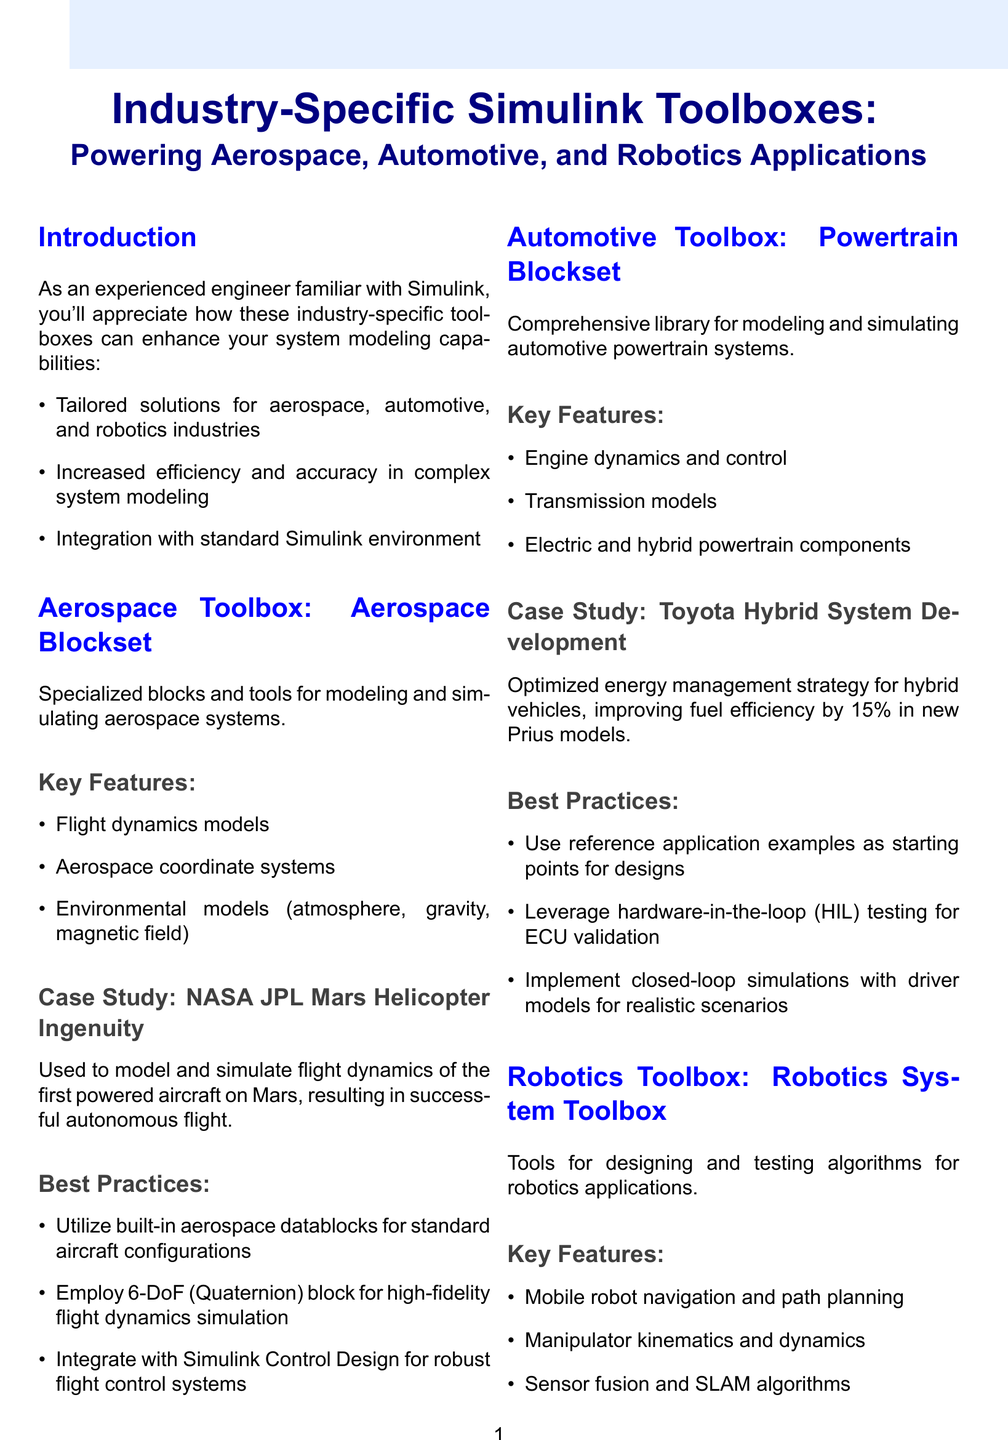What is the name of the aerospace toolbox? The aerospace toolbox is named in the section dedicated to it, which explicitly states "Aerospace Blockset."
Answer: Aerospace Blockset What was the outcome of the NASA JPL Mars Helicopter Ingenuity case study? The document describes the outcome of this case study as a successful autonomous flight on Mars, validating simulation accuracy.
Answer: Successful autonomous flight on Mars What percentage of fuel efficiency improvement was achieved in the Toyota Hybrid System Development case study? The improvement percentage is specifically mentioned as "15%" in relation to the new Prius models.
Answer: 15% What tool is suggested for high-fidelity flight dynamics simulation in the aerospace best practices? A specific block is indicated in the best practices section as being beneficial for high-fidelity flight dynamics simulation.
Answer: 6-DoF (Quaternion) block What type of behavior does reinforcement learning help with in robotics applications? The document states that reinforcement learning techniques are implemented for adaptive behaviors of robots.
Answer: Adaptive robot behaviors How many industry-specific toolboxes are mentioned in the document? The introduction lays out three key industries, each associated with a toolbox that enhances specific modeling capabilities.
Answer: Three What is one of the cross-industry benefits listed in the document? The document highlights various benefits that span across industries, including accelerated development cycles through rapid prototyping as one of the key advantages.
Answer: Accelerated development cycles through rapid prototyping What is the main focus of the Robotics System Toolbox as described? The overview focuses on designing and testing algorithms tailored specifically for robotics applications.
Answer: Designing and testing algorithms for robotics applications 